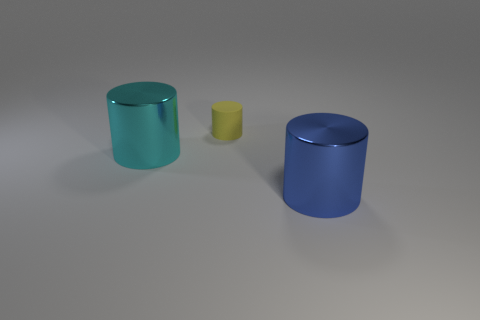Can you guess the texture of the objects? All three cylinders in the image have a smooth texture, evident from their reflective surfaces. The specular highlights and lack of visible grain or irregularities suggest that the materials would feel sleek and cool to the touch. 